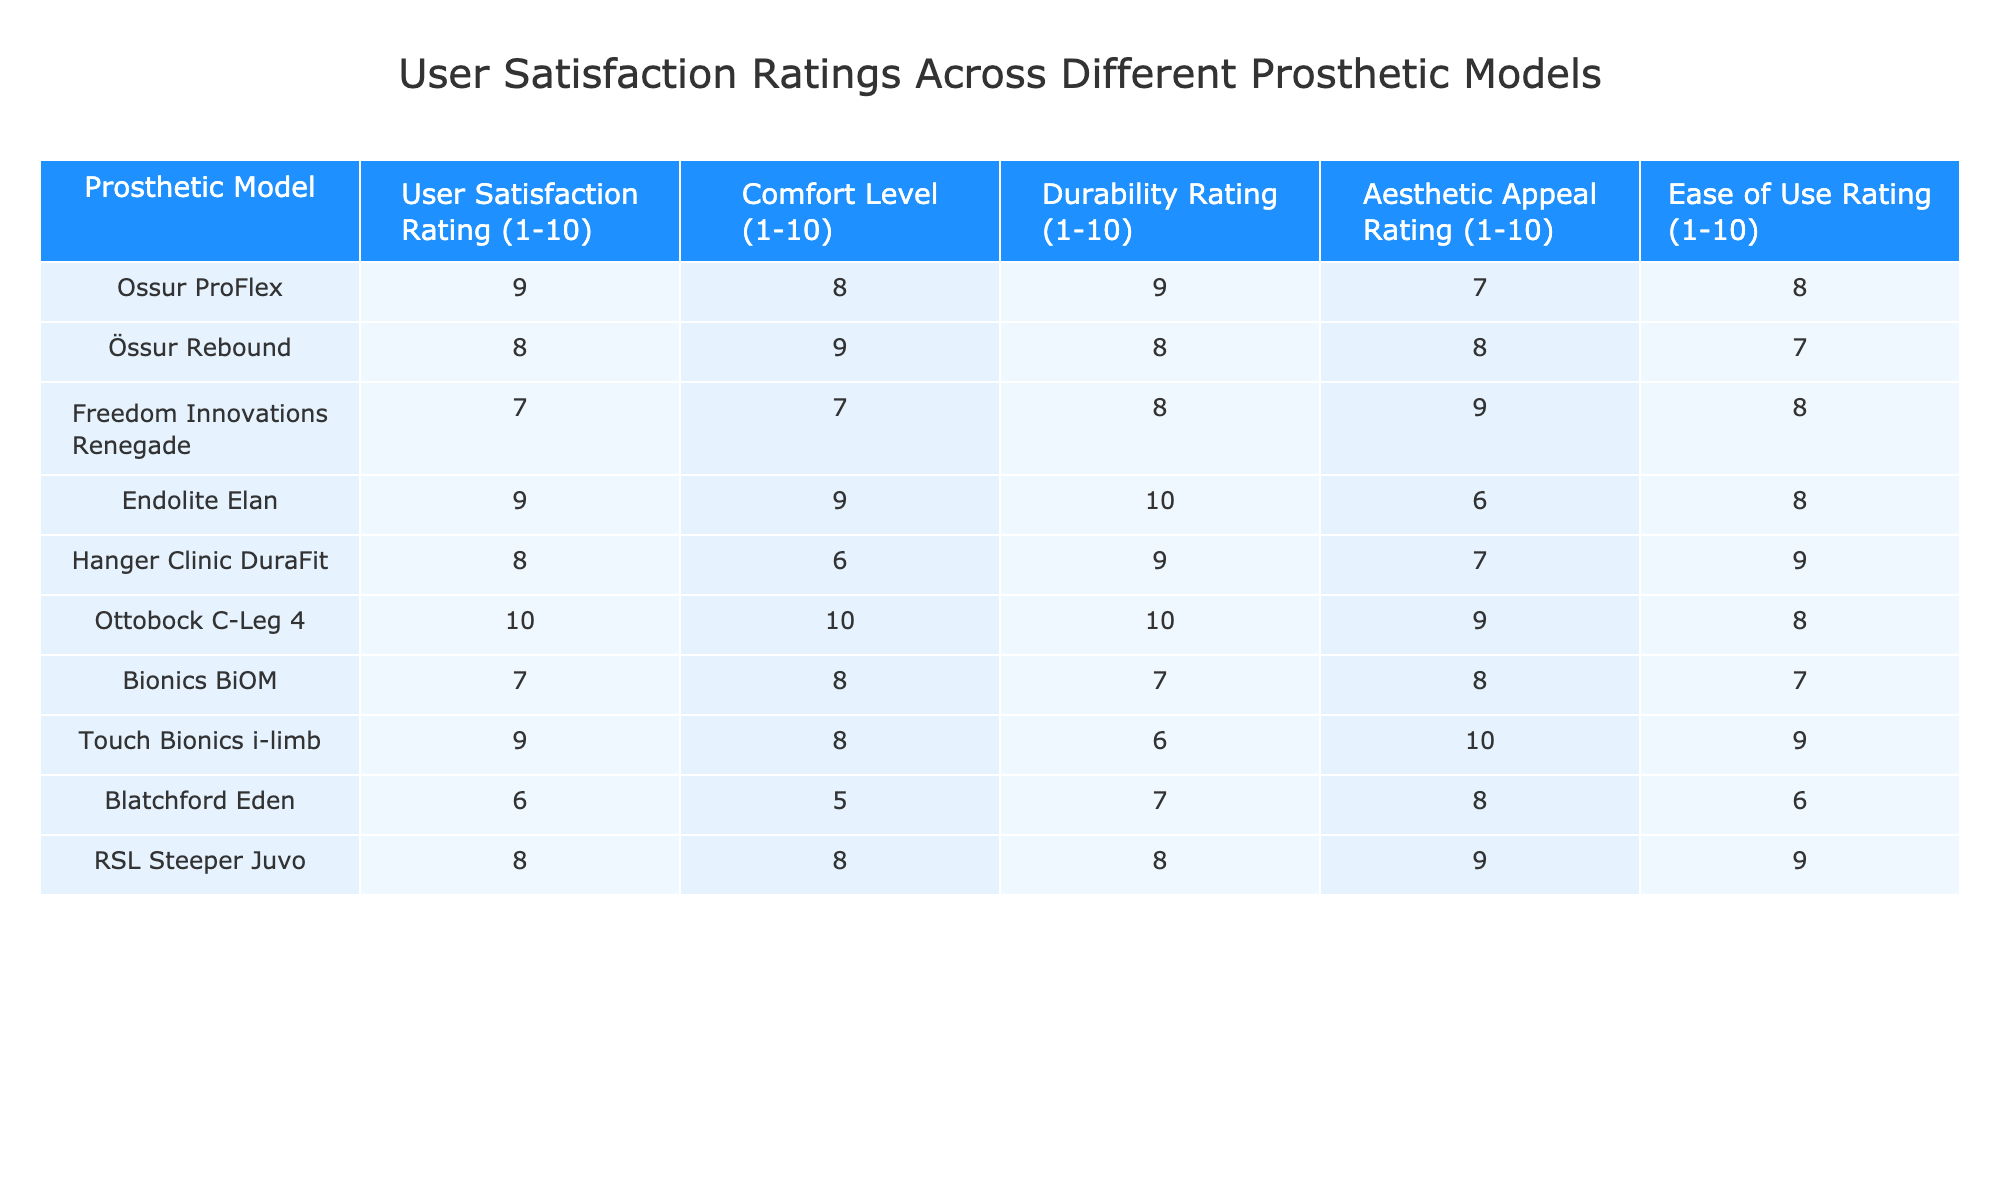What is the user satisfaction rating for the Ottobock C-Leg 4? The user satisfaction rating for the Ottobock C-Leg 4 is listed in the table as 10.
Answer: 10 Which model has the highest durability rating? By checking the durability ratings for each model, the Ottobock C-Leg 4 shows a durability rating of 10, which is the highest among all models listed.
Answer: Ottobock C-Leg 4 What is the average comfort level rating across all prosthetic models? To find the average comfort level, add all the comfort levels: 8 + 9 + 7 + 9 + 6 + 10 + 8 + 8 + 5 + 8 = 78. There are 10 models, therefore the average is 78/10 = 7.8.
Answer: 7.8 Is the Freedom Innovations Renegade rated higher for aesthetic appeal than the Hanger Clinic DuraFit? The Freedom Innovations Renegade has an aesthetic appeal rating of 9 while the Hanger Clinic DuraFit has a rating of 7. Since 9 is greater than 7, the answer is yes.
Answer: Yes What is the difference in the user satisfaction rating between the Touch Bionics i-limb and the Blatchford Eden models? The user satisfaction rating for Touch Bionics i-limb is 9 and for Blatchford Eden is 6. The difference is 9 - 6 = 3.
Answer: 3 Which models have a comfort level rating above 8, and how many such models are there? The comfort level ratings above 8 are: Ottobock C-Leg 4 (10), Össur Rebound (9), and Endolite Elan (9). Thus, there are 3 models with a comfort level rating above 8.
Answer: 3 What percentage of the models scored a user satisfaction rating of 8 or higher? There are 10 models in total, and those with a rating of 8 or higher are: Ossur ProFlex (9), Össur Rebound (8), Endolite Elan (9), Ottobock C-Leg 4 (10), Touch Bionics i-limb (9), and RSL Steeper Juvo (8). That's 6 models, so the percentage is (6/10) * 100 = 60%.
Answer: 60% Is the average aesthetic appeal rating less than 7? Adding all aesthetic appeal ratings: 7 + 8 + 9 + 6 + 7 + 9 + 10 + 8 + 8 + 6 = 78. The average is 78/10 = 7.8, which is greater than 7. Therefore, the statement is false.
Answer: No 